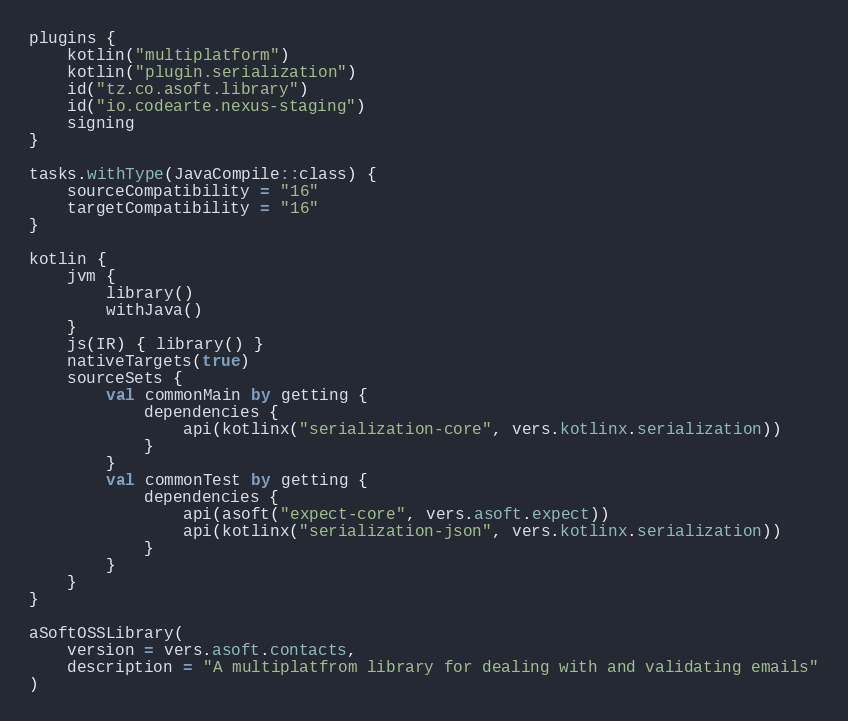Convert code to text. <code><loc_0><loc_0><loc_500><loc_500><_Kotlin_>plugins {
    kotlin("multiplatform")
    kotlin("plugin.serialization")
    id("tz.co.asoft.library")
    id("io.codearte.nexus-staging")
    signing
}

tasks.withType(JavaCompile::class) {
    sourceCompatibility = "16"
    targetCompatibility = "16"
}

kotlin {
    jvm {
        library()
        withJava()
    }
    js(IR) { library() }
    nativeTargets(true)
    sourceSets {
        val commonMain by getting {
            dependencies {
                api(kotlinx("serialization-core", vers.kotlinx.serialization))
            }
        }
        val commonTest by getting {
            dependencies {
                api(asoft("expect-core", vers.asoft.expect))
                api(kotlinx("serialization-json", vers.kotlinx.serialization))
            }
        }
    }
}

aSoftOSSLibrary(
    version = vers.asoft.contacts,
    description = "A multiplatfrom library for dealing with and validating emails"
)</code> 